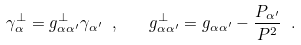Convert formula to latex. <formula><loc_0><loc_0><loc_500><loc_500>\gamma _ { \alpha } ^ { \perp } = g _ { \alpha \alpha ^ { \prime } } ^ { \perp } \gamma _ { \alpha ^ { \prime } } \ , \quad g _ { \alpha \alpha ^ { \prime } } ^ { \perp } = g _ { \alpha \alpha ^ { \prime } } - \frac { P _ { \alpha ^ { \prime } } } { P ^ { 2 } } \ .</formula> 